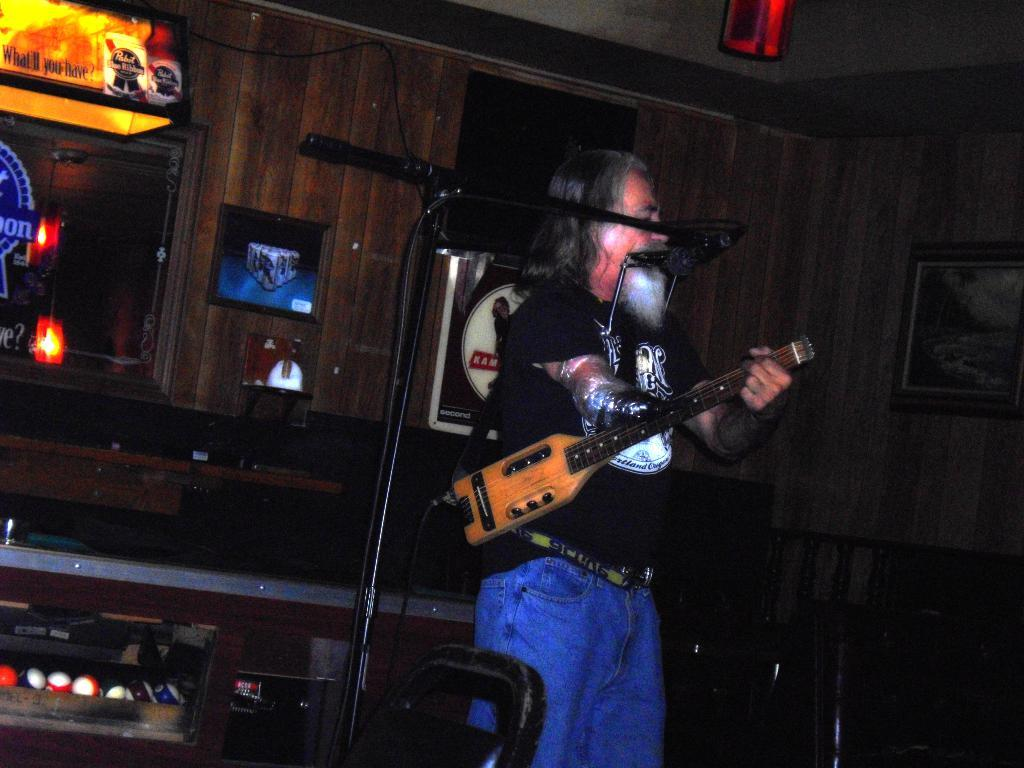<image>
Render a clear and concise summary of the photo. A yellow light over a pool table asks "What'll you have?" 